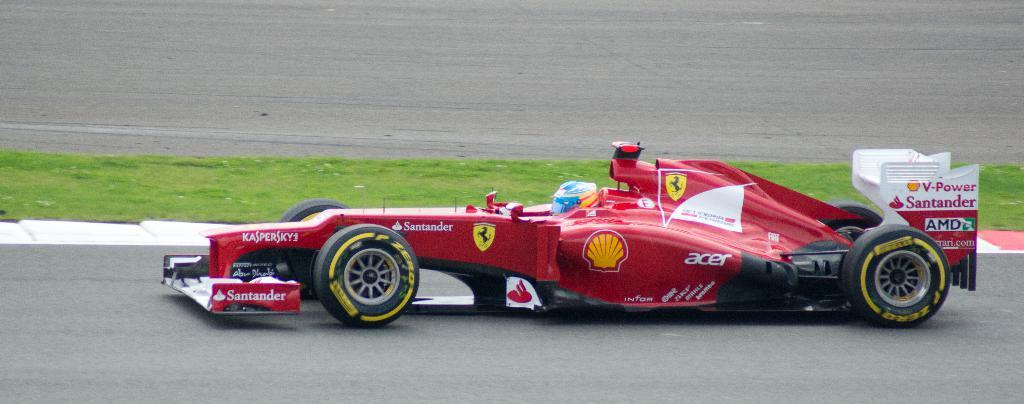What is the main subject of the image? The main subject of the image is a person driving a car. What can be seen in the background of the image? There is a grassy land at the center of the image. What type of value is being traded in the image? There is no indication of any trading or value exchange in the image; it features a person driving a car and a grassy land. What type of apparel is the person driving the car wearing? The provided facts do not mention any specific apparel worn by the person driving the car. 